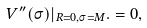<formula> <loc_0><loc_0><loc_500><loc_500>V ^ { \prime \prime } ( \sigma ) | _ { R = 0 , \sigma = M } . = 0 ,</formula> 